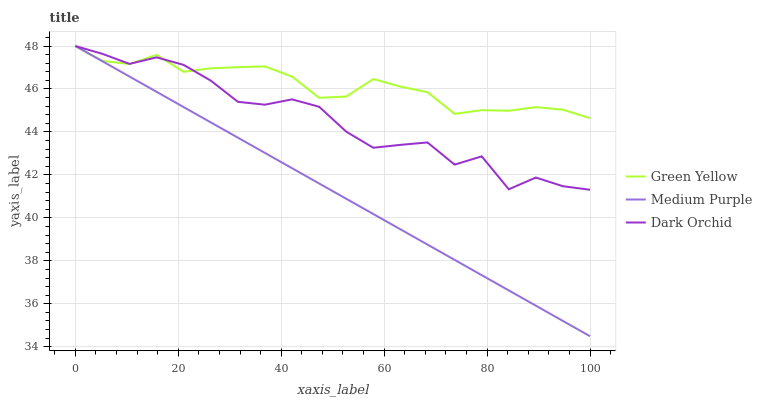Does Dark Orchid have the minimum area under the curve?
Answer yes or no. No. Does Dark Orchid have the maximum area under the curve?
Answer yes or no. No. Is Green Yellow the smoothest?
Answer yes or no. No. Is Green Yellow the roughest?
Answer yes or no. No. Does Dark Orchid have the lowest value?
Answer yes or no. No. 